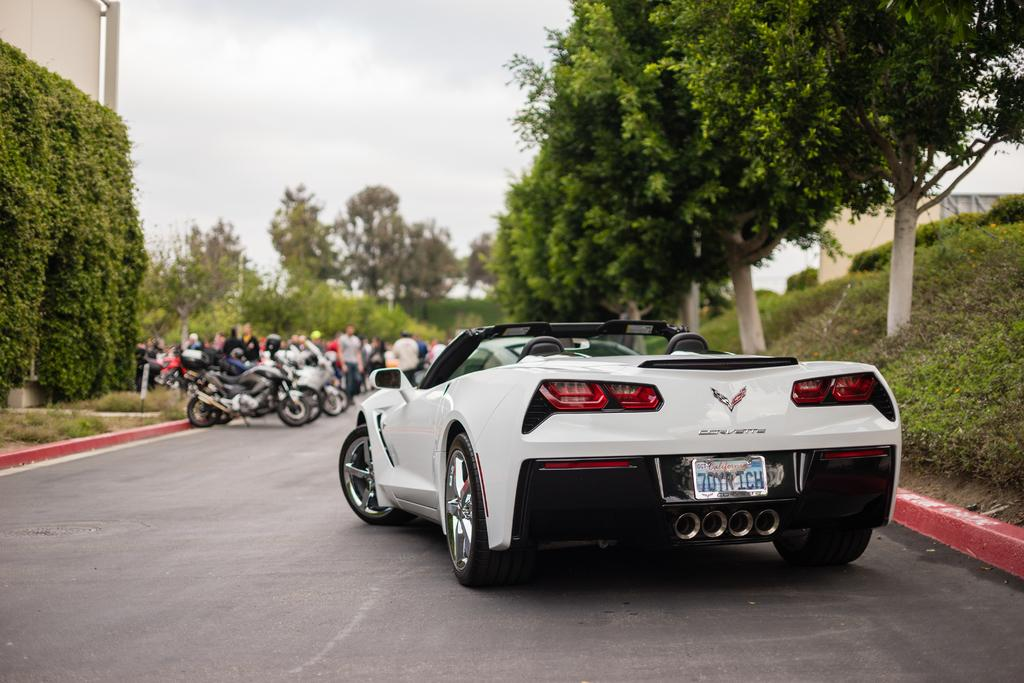What can be seen in the image? There are people standing in the image, along with vehicles, trees, grass, plants, and the sky visible in the background. Can you describe the people in the image? The facts provided do not give specific details about the people in the image. What type of vehicles are present in the image? The facts provided do not specify the type of vehicles in the image. What is the natural environment like in the image? The natural environment in the image includes trees, grass, and plants. What is visible in the background of the image? The sky is visible in the background of the image. How does the memory of the people in the image affect their ability to spy on the plants? There is no mention of memory, spying, or plants affecting the people in the image. The image only shows people standing with vehicles, trees, grass, plants, and the sky visible in the background. 